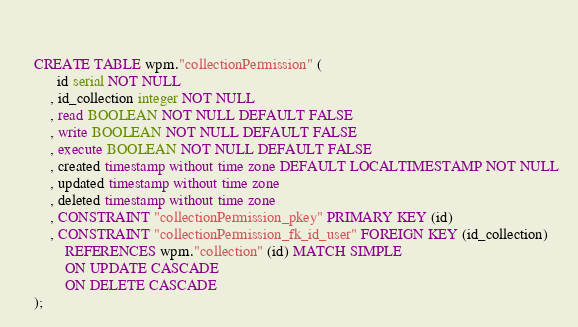Convert code to text. <code><loc_0><loc_0><loc_500><loc_500><_SQL_>
	

	CREATE TABLE wpm."collectionPermission" (
		  id serial NOT NULL
		, id_collection integer NOT NULL
		, read BOOLEAN NOT NULL DEFAULT FALSE
		, write BOOLEAN NOT NULL DEFAULT FALSE
		, execute BOOLEAN NOT NULL DEFAULT FALSE
		, created timestamp without time zone DEFAULT LOCALTIMESTAMP NOT NULL
		, updated timestamp without time zone
		, deleted timestamp without time zone
	  	, CONSTRAINT "collectionPermission_pkey" PRIMARY KEY (id)
	  	, CONSTRAINT "collectionPermission_fk_id_user" FOREIGN KEY (id_collection)
	  		REFERENCES wpm."collection" (id) MATCH SIMPLE
	  		ON UPDATE CASCADE
	  		ON DELETE CASCADE
	);</code> 